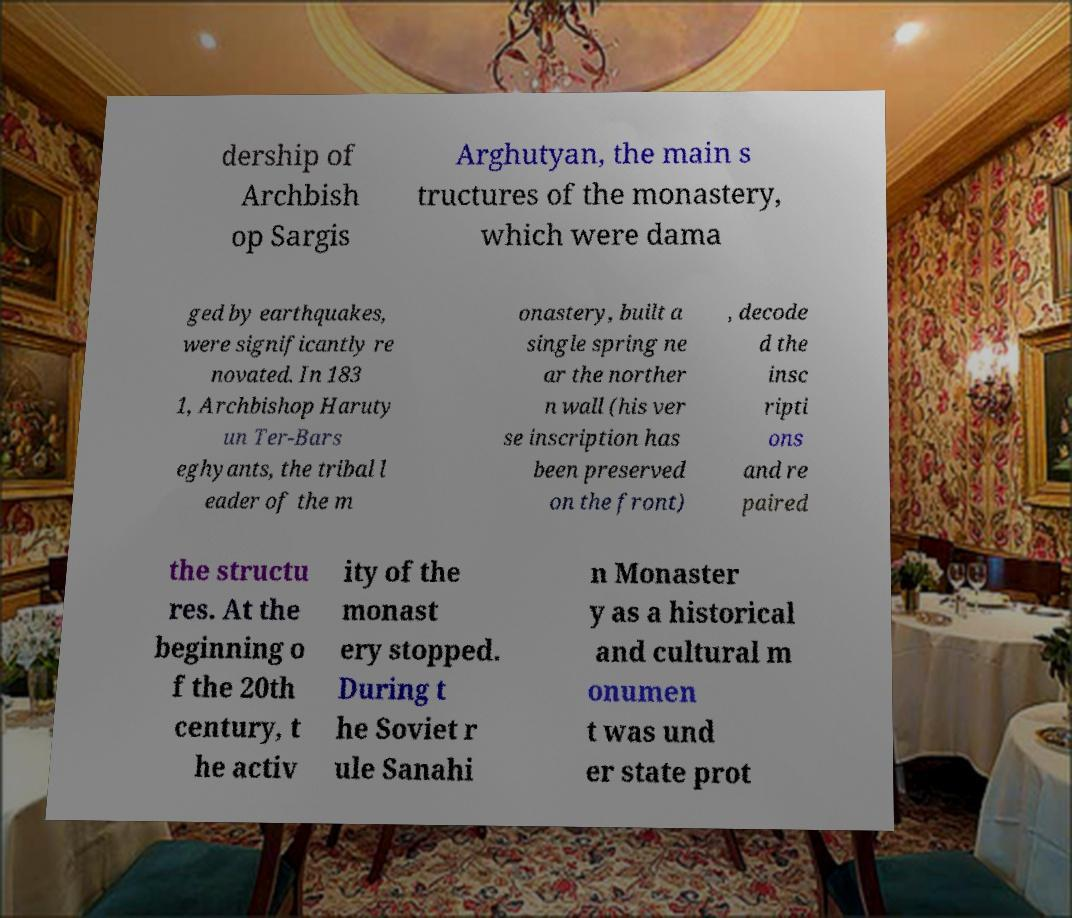Can you accurately transcribe the text from the provided image for me? dership of Archbish op Sargis Arghutyan, the main s tructures of the monastery, which were dama ged by earthquakes, were significantly re novated. In 183 1, Archbishop Haruty un Ter-Bars eghyants, the tribal l eader of the m onastery, built a single spring ne ar the norther n wall (his ver se inscription has been preserved on the front) , decode d the insc ripti ons and re paired the structu res. At the beginning o f the 20th century, t he activ ity of the monast ery stopped. During t he Soviet r ule Sanahi n Monaster y as a historical and cultural m onumen t was und er state prot 